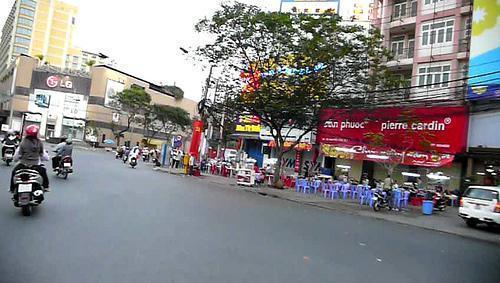Why is the motorcycle rider wearing a red helmet?
Select the accurate response from the four choices given to answer the question.
Options: Punishment, fashion, visibility, protection. Protection. 